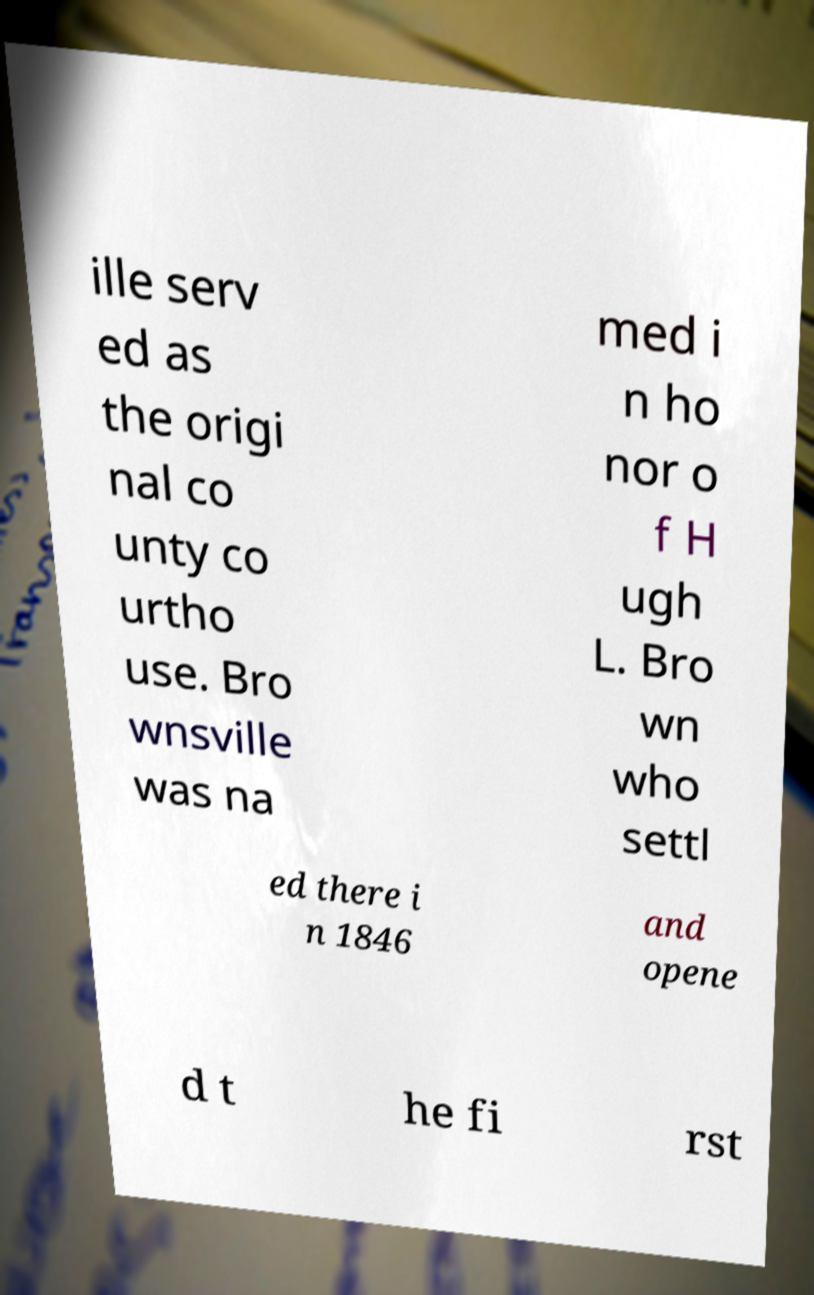Please read and relay the text visible in this image. What does it say? ille serv ed as the origi nal co unty co urtho use. Bro wnsville was na med i n ho nor o f H ugh L. Bro wn who settl ed there i n 1846 and opene d t he fi rst 